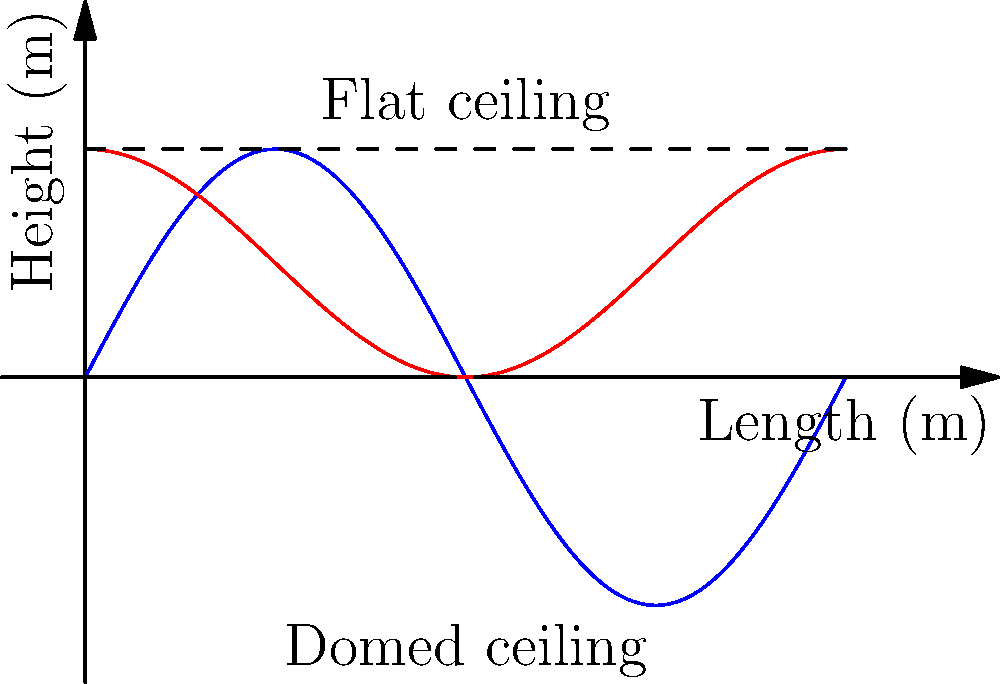As a Hindu priest consulting with an acoustics expert to improve the sound quality in your prayer hall during festivals, you're presented with two ceiling designs: a domed ceiling (blue) and a flat ceiling (red). The hall is 10 meters long. If the sound reflection coefficient is directly proportional to the ceiling height, which design would provide better sound distribution throughout the hall, and why? To determine which ceiling design provides better sound distribution, we need to consider the following factors:

1. Ceiling height variation:
   - Domed ceiling: Height varies from 0 to 3 meters
   - Flat ceiling: Constant height of 1.5 meters

2. Sound reflection principle:
   - Higher ceilings reflect sound less, allowing it to travel further
   - Lower ceilings reflect sound more, concentrating it in specific areas

3. Sound distribution analysis:
   a) Domed ceiling:
      - Center (highest point): Less reflection, sound travels further
      - Edges (lowest points): More reflection, sound concentrates near walls
      - Result: Varied sound distribution throughout the hall

   b) Flat ceiling:
      - Consistent height: Uniform reflection throughout the hall
      - Result: Even sound distribution across the space

4. Considering the religious context:
   - Festivals often involve chanting and group prayers
   - Even sound distribution ensures all participants can hear clearly

5. Conclusion:
   The flat ceiling (red) would provide better sound distribution throughout the hall because:
   - It offers consistent sound reflection across the entire length
   - It ensures uniform sound levels for all participants
   - It prevents sound concentration in specific areas, which could occur with the domed design

While the domed ceiling might create interesting acoustic effects, the flat ceiling is more suitable for clear and even sound distribution during religious festivals.
Answer: Flat ceiling (red) for consistent sound reflection and even distribution. 